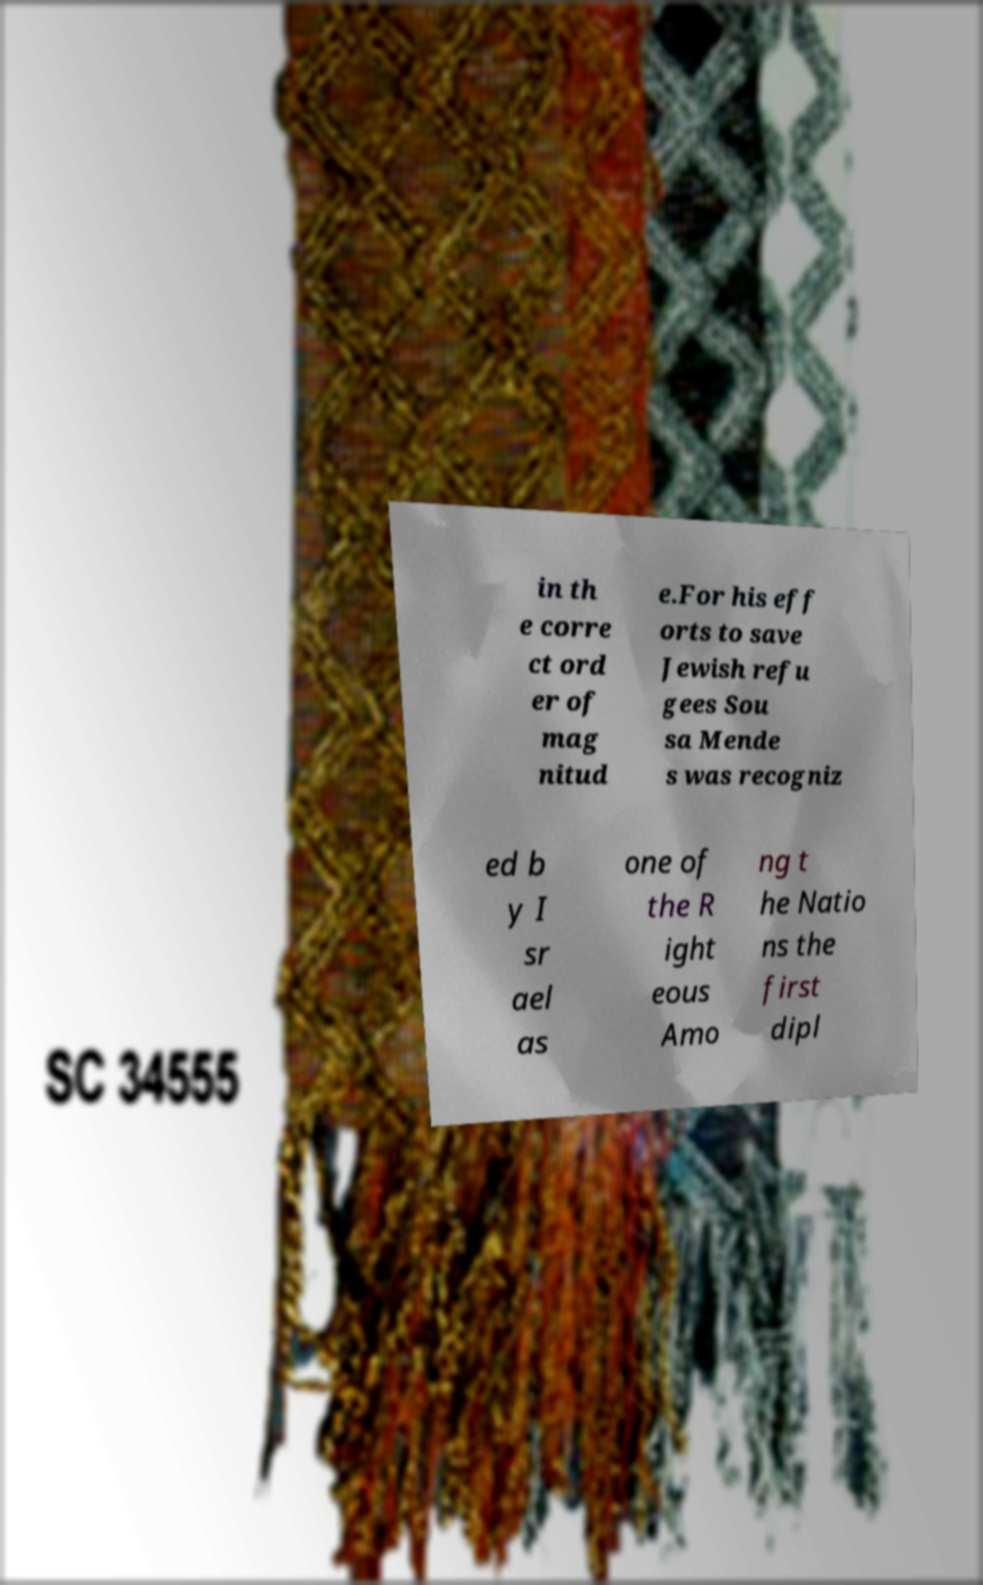Can you read and provide the text displayed in the image?This photo seems to have some interesting text. Can you extract and type it out for me? in th e corre ct ord er of mag nitud e.For his eff orts to save Jewish refu gees Sou sa Mende s was recogniz ed b y I sr ael as one of the R ight eous Amo ng t he Natio ns the first dipl 